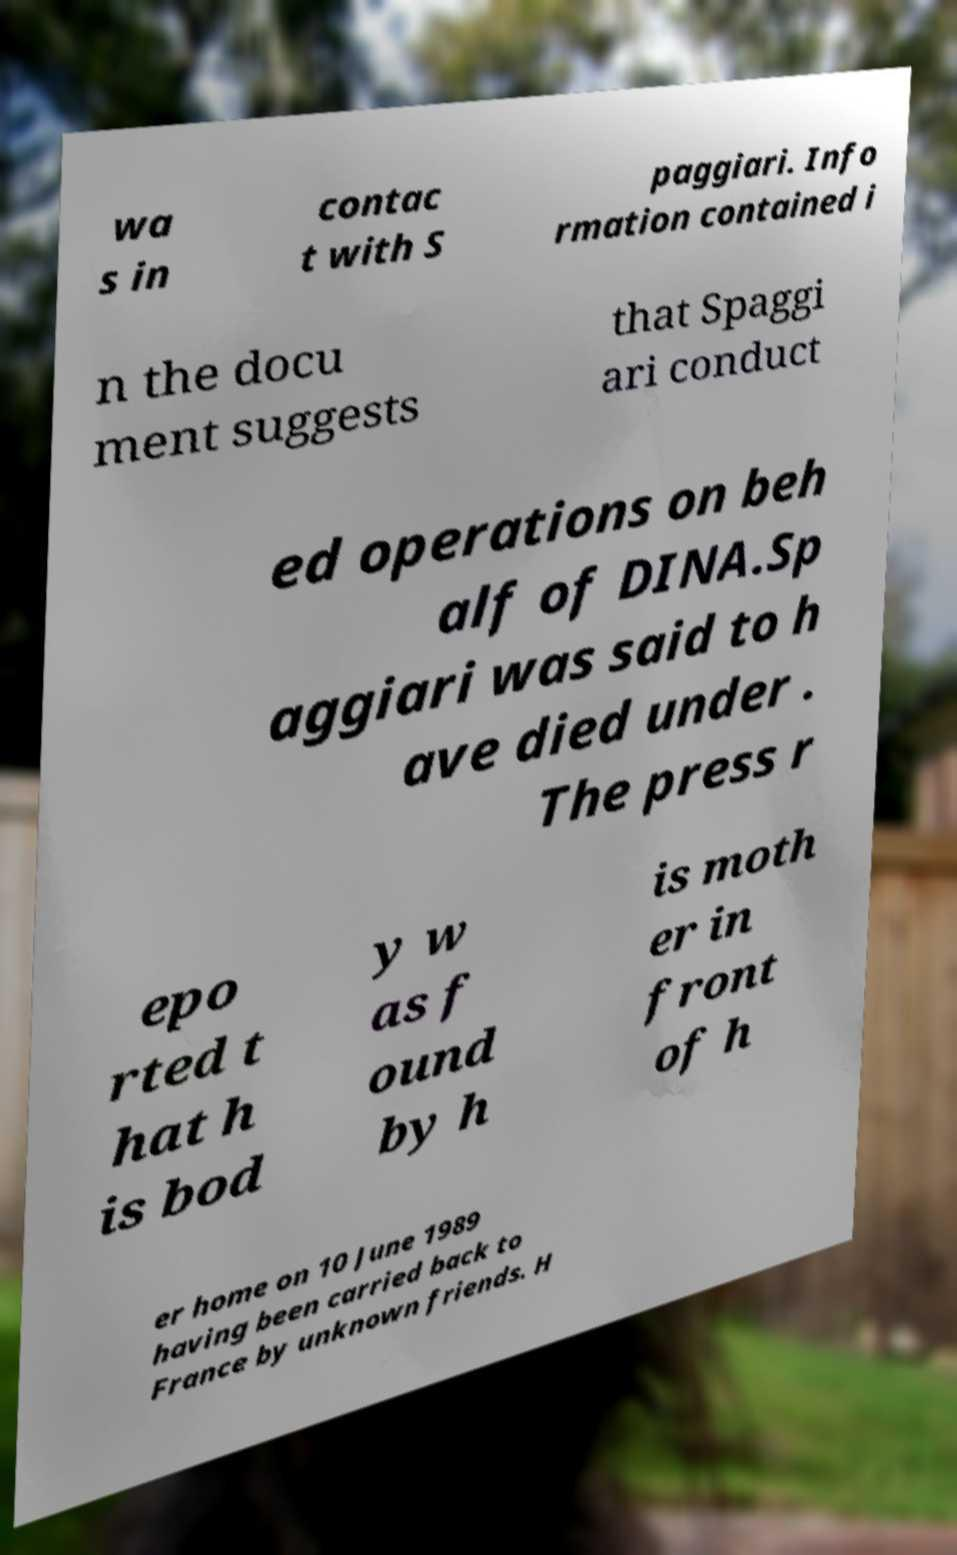Can you accurately transcribe the text from the provided image for me? wa s in contac t with S paggiari. Info rmation contained i n the docu ment suggests that Spaggi ari conduct ed operations on beh alf of DINA.Sp aggiari was said to h ave died under . The press r epo rted t hat h is bod y w as f ound by h is moth er in front of h er home on 10 June 1989 having been carried back to France by unknown friends. H 